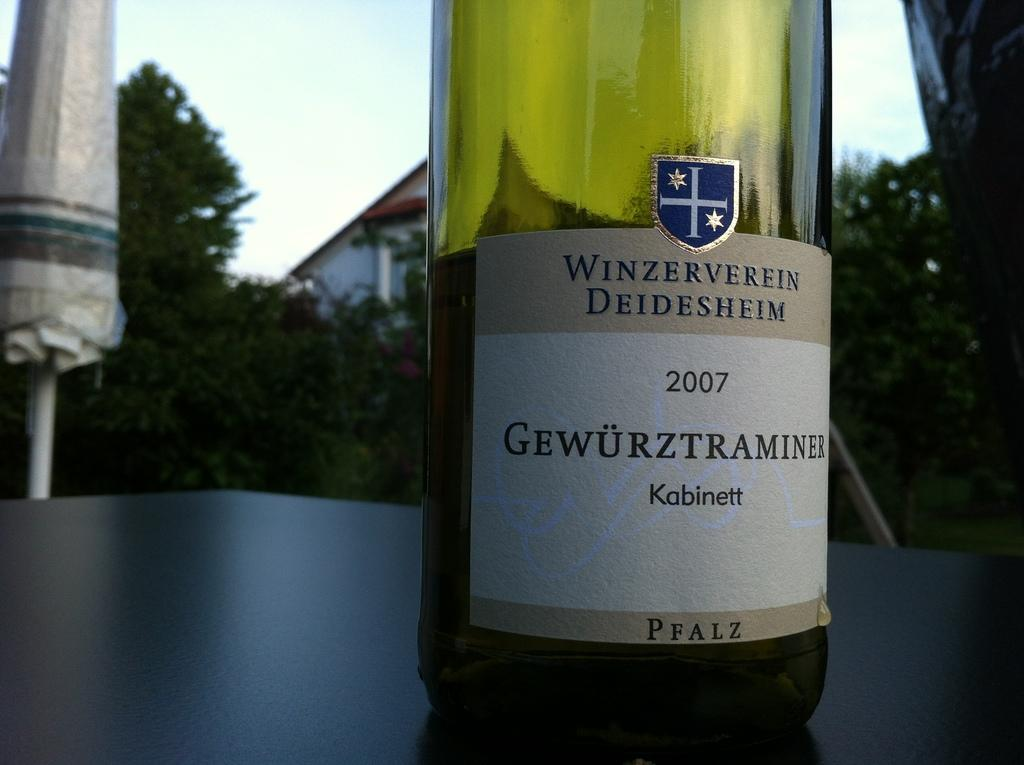<image>
Give a short and clear explanation of the subsequent image. A bottle of winw is from Winzerverein Deidesheim. 